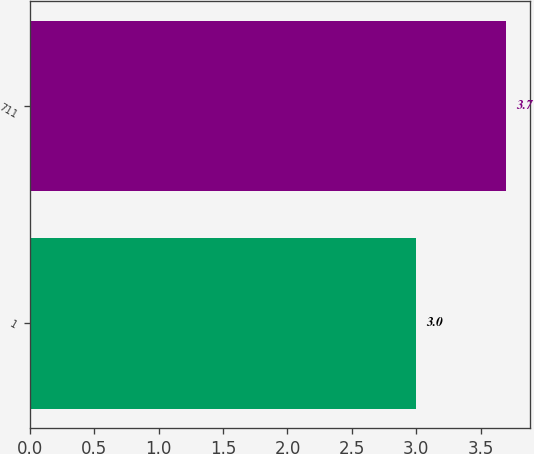<chart> <loc_0><loc_0><loc_500><loc_500><bar_chart><fcel>1<fcel>711<nl><fcel>3<fcel>3.7<nl></chart> 